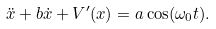Convert formula to latex. <formula><loc_0><loc_0><loc_500><loc_500>\ddot { x } + b \dot { x } + V ^ { \prime } ( x ) = a \cos ( \omega _ { 0 } t ) .</formula> 